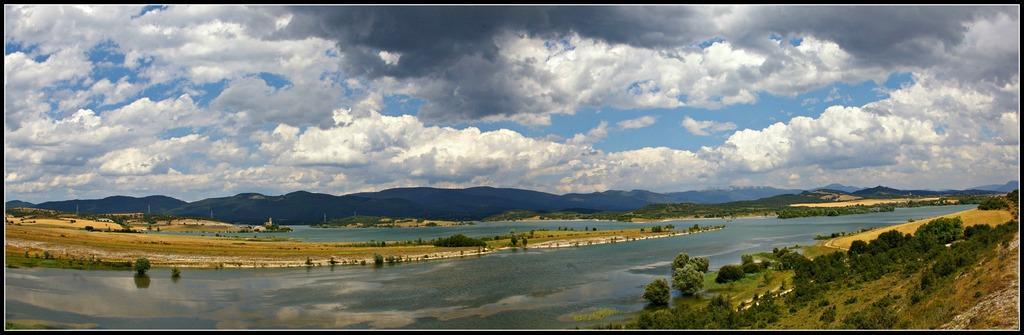Could you give a brief overview of what you see in this image? In this image we can see a large water body and some trees on the land. On the backside we can see some poles, mountains and the sky which looks cloudy. 